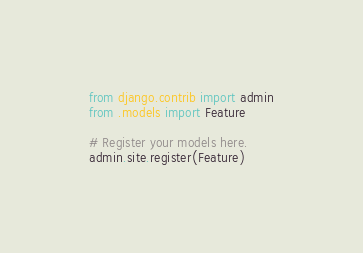Convert code to text. <code><loc_0><loc_0><loc_500><loc_500><_Python_>from django.contrib import admin
from .models import Feature

# Register your models here.
admin.site.register(Feature)</code> 